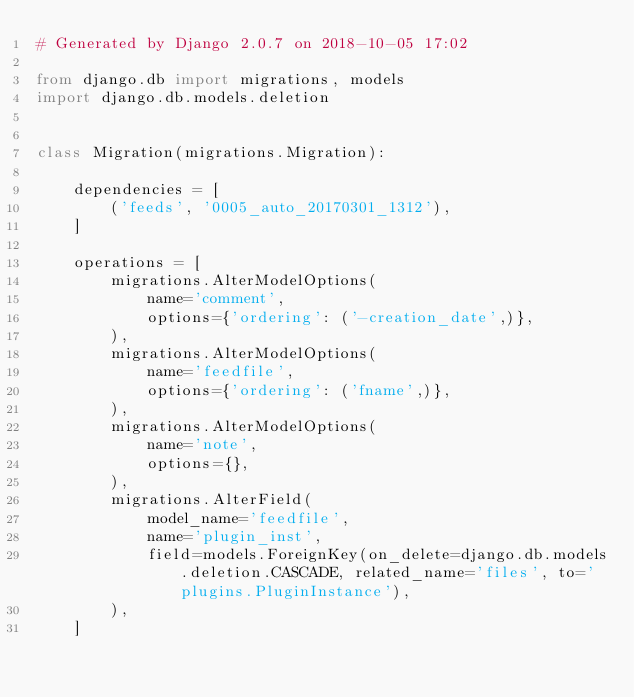Convert code to text. <code><loc_0><loc_0><loc_500><loc_500><_Python_># Generated by Django 2.0.7 on 2018-10-05 17:02

from django.db import migrations, models
import django.db.models.deletion


class Migration(migrations.Migration):

    dependencies = [
        ('feeds', '0005_auto_20170301_1312'),
    ]

    operations = [
        migrations.AlterModelOptions(
            name='comment',
            options={'ordering': ('-creation_date',)},
        ),
        migrations.AlterModelOptions(
            name='feedfile',
            options={'ordering': ('fname',)},
        ),
        migrations.AlterModelOptions(
            name='note',
            options={},
        ),
        migrations.AlterField(
            model_name='feedfile',
            name='plugin_inst',
            field=models.ForeignKey(on_delete=django.db.models.deletion.CASCADE, related_name='files', to='plugins.PluginInstance'),
        ),
    ]
</code> 